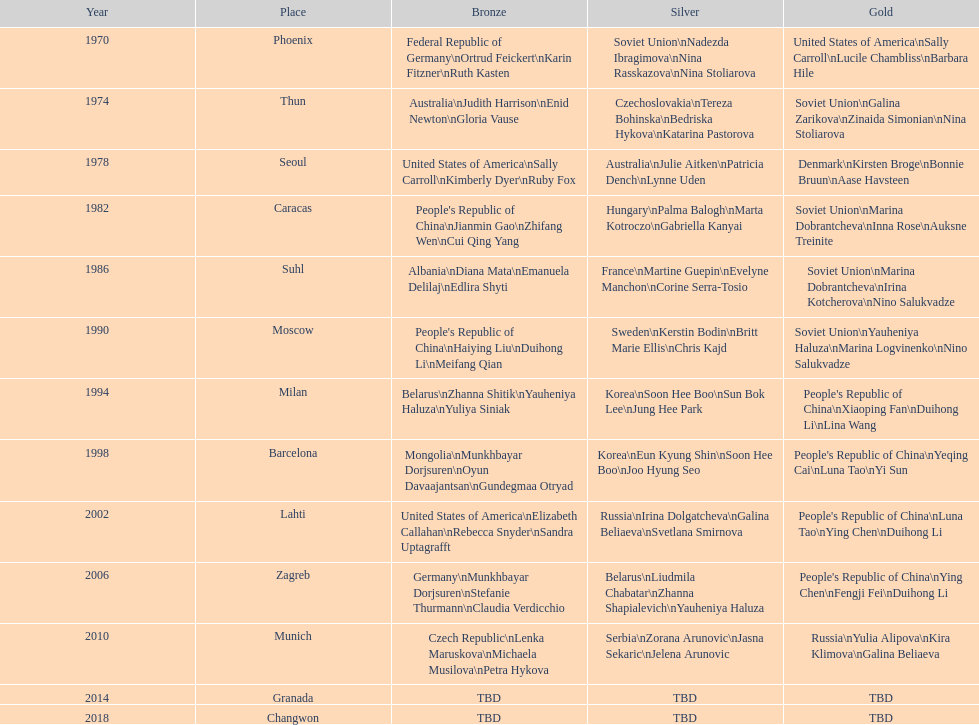What is the number of total bronze medals that germany has won? 1. 